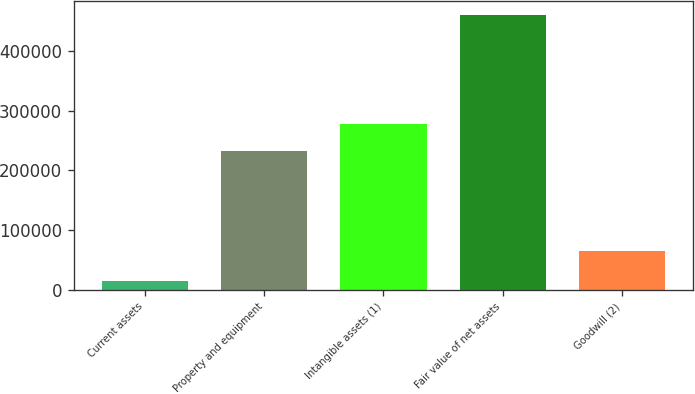Convert chart. <chart><loc_0><loc_0><loc_500><loc_500><bar_chart><fcel>Current assets<fcel>Property and equipment<fcel>Intangible assets (1)<fcel>Fair value of net assets<fcel>Goodwill (2)<nl><fcel>14483<fcel>233073<fcel>277654<fcel>460288<fcel>65365<nl></chart> 